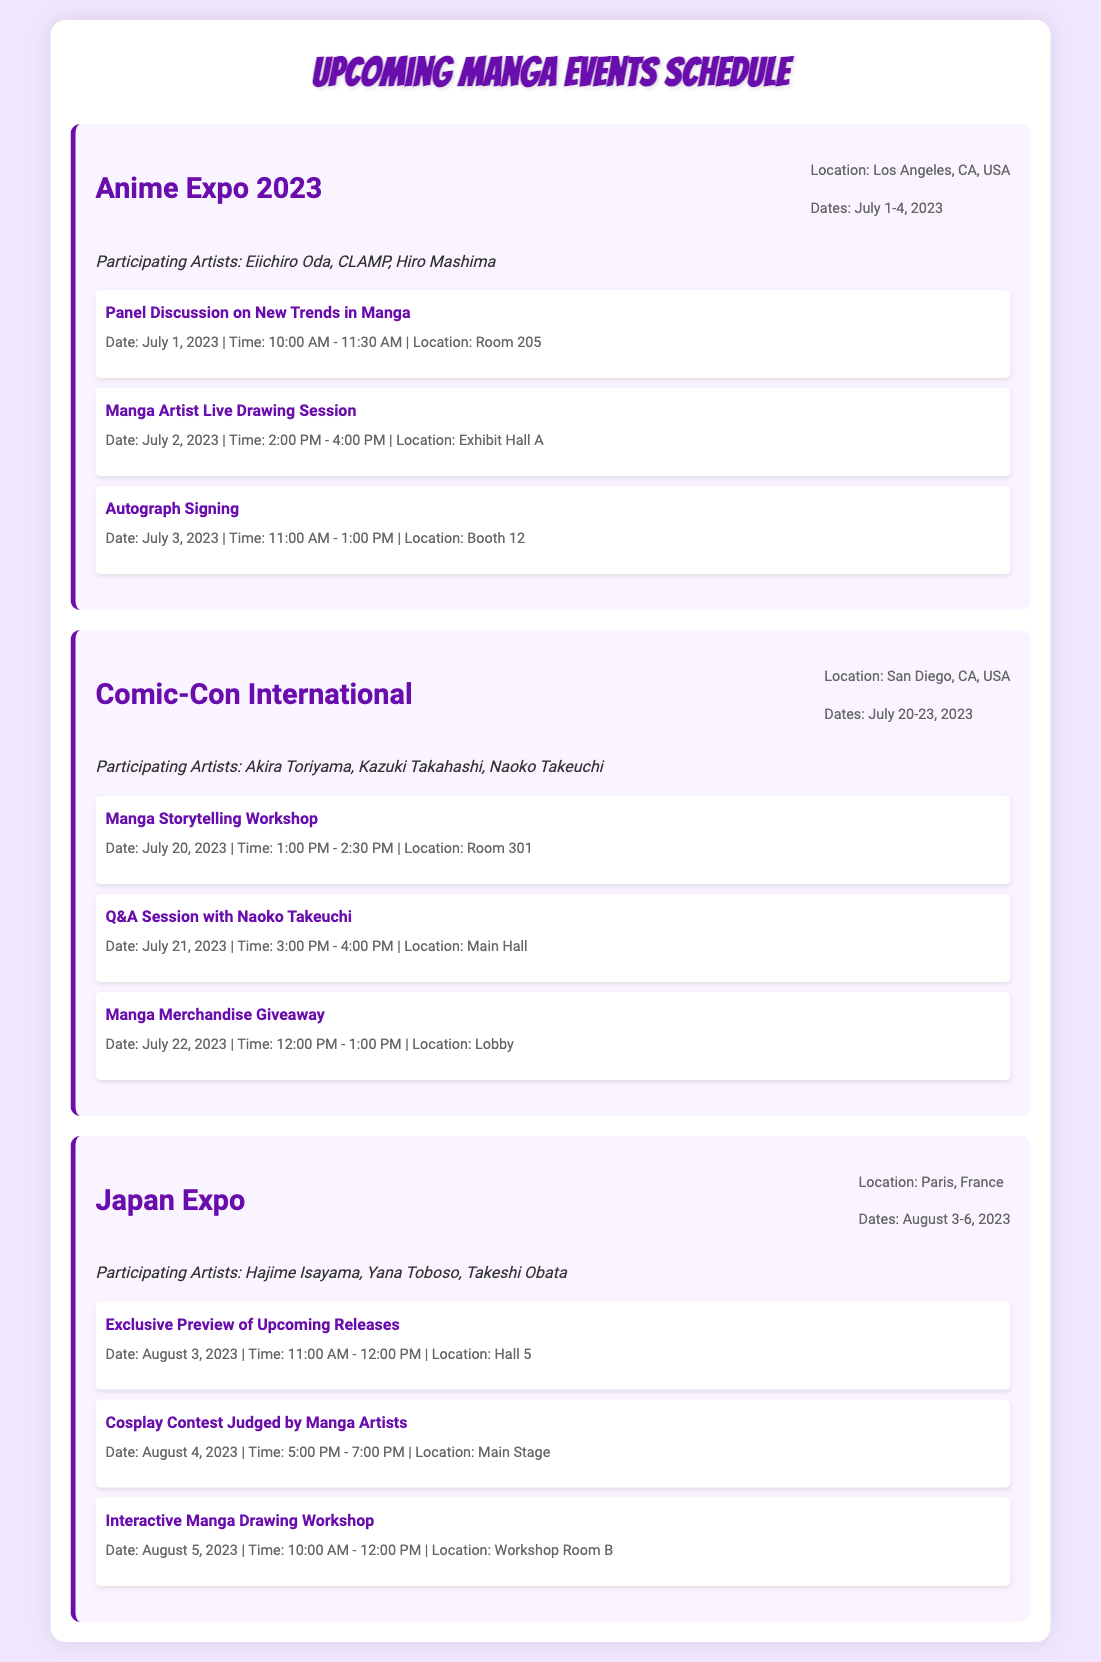What is the location of Anime Expo 2023? The document states that Anime Expo 2023 is located in Los Angeles, CA, USA.
Answer: Los Angeles, CA, USA Who are the participating artists at Comic-Con International? The document lists Akira Toriyama, Kazuki Takahashi, and Naoko Takeuchi as participating artists at Comic-Con International.
Answer: Akira Toriyama, Kazuki Takahashi, Naoko Takeuchi What date is the Manga Artist Live Drawing Session at Anime Expo? The document provides that the Manga Artist Live Drawing Session is scheduled for July 2, 2023.
Answer: July 2, 2023 How many days does Japan Expo 2023 last? The document indicates that Japan Expo 2023 runs from August 3 to August 6, which is four days.
Answer: 4 days What type of activity will occur on August 4 at Japan Expo? The document mentions a Cosplay Contest Judged by Manga Artists on August 4.
Answer: Cosplay Contest Judged by Manga Artists Which event features a Q&A Session with Naoko Takeuchi? The document states that Comic-Con International features a Q&A Session with Naoko Takeuchi.
Answer: Comic-Con International What is the date for the Interactive Manga Drawing Workshop at Japan Expo? The document states that the Interactive Manga Drawing Workshop will take place on August 5, 2023.
Answer: August 5, 2023 What is the main theme of the panel discussion at Anime Expo? The document notes that the theme is New Trends in Manga.
Answer: New Trends in Manga How many activities are listed for Comic-Con International? There are three activities listed for Comic-Con International in the document.
Answer: 3 activities 